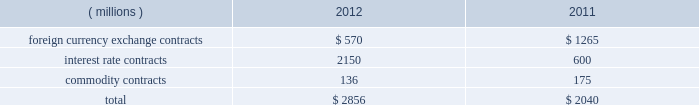Note 12 derivative instruments and fair value measurements the company is exposed to certain market risks such as changes in interest rates , foreign currency exchange rates , and commodity prices , which exist as a part of its ongoing business operations .
Management uses derivative financial and commodity instruments , including futures , options , and swaps , where appropriate , to manage these risks .
Instruments used as hedges must be effective at reducing the risk associated with the exposure being hedged and must be designated as a hedge at the inception of the contract .
The company designates derivatives as cash flow hedges , fair value hedges , net investment hedges , and uses other contracts to reduce volatility in interest rates , foreign currency and commodities .
As a matter of policy , the company does not engage in trading or speculative hedging transactions .
Total notional amounts of the company 2019s derivative instruments as of december 29 , 2012 and december 31 , 2011 were as follows: .
Following is a description of each category in the fair value hierarchy and the financial assets and liabilities of the company that were included in each category at december 29 , 2012 and december 31 , 2011 , measured on a recurring basis .
Level 1 2014 financial assets and liabilities whose values are based on unadjusted quoted prices for identical assets or liabilities in an active market .
For the company , level 1 financial assets and liabilities consist primarily of commodity derivative contracts .
Level 2 2014 financial assets and liabilities whose values are based on quoted prices in markets that are not active or model inputs that are observable either directly or indirectly for substantially the full term of the asset or liability .
For the company , level 2 financial assets and liabilities consist of interest rate swaps and over-the-counter commodity and currency contracts .
The company 2019s calculation of the fair value of interest rate swaps is derived from a discounted cash flow analysis based on the terms of the contract and the interest rate curve .
Over-the-counter commodity derivatives are valued using an income approach based on the commodity index prices less the contract rate multiplied by the notional amount .
Foreign currency contracts are valued using an income approach based on forward rates less the contract rate multiplied by the notional amount .
The company 2019s calculation of the fair value of level 2 financial assets and liabilities takes into consideration the risk of nonperformance , including counterparty credit risk .
Level 3 2014 financial assets and liabilities whose values are based on prices or valuation techniques that require inputs that are both unobservable and significant to the overall fair value measurement .
These inputs reflect management 2019s own assumptions about the assumptions a market participant would use in pricing the asset or liability .
The company did not have any level 3 financial assets or liabilities as of december 29 , 2012 or december 31 , 2011 .
The following table presents assets and liabilities that were measured at fair value in the consolidated balance sheet on a recurring basis as of december 29 , 2012 and december 31 , 2011 : derivatives designated as hedging instruments : 2012 2011 ( millions ) level 1 level 2 total level 1 level 2 total assets : foreign currency exchange contracts : other current assets $ 2014 $ 4 $ 4 $ 2014 $ 11 $ 11 interest rate contracts ( a ) : other assets 2014 64 64 2014 23 23 commodity contracts : other current assets 2014 2014 2014 2 2014 2 total assets $ 2014 $ 68 $ 68 $ 2 $ 34 $ 36 liabilities : foreign currency exchange contracts : other current liabilities $ 2014 $ ( 3 ) $ ( 3 ) $ 2014 $ ( 18 ) $ ( 18 ) commodity contracts : other current liabilities 2014 ( 11 ) ( 11 ) ( 4 ) ( 12 ) ( 16 ) other liabilities 2014 ( 27 ) ( 27 ) 2014 ( 34 ) ( 34 ) total liabilities $ 2014 $ ( 41 ) $ ( 41 ) $ ( 4 ) $ ( 64 ) $ ( 68 ) ( a ) the fair value of the related hedged portion of the company 2019s long-term debt , a level 2 liability , was $ 2.3 billion as of december 29 , 2012 and $ 626 million as of december 31 , derivatives not designated as hedging instruments : 2012 2011 ( millions ) level 1 level 2 total level 1 level 2 total assets : commodity contracts : other current assets $ 5 $ 2014 $ 5 $ 2014 $ 2014 $ 2014 total assets $ 5 $ 2014 $ 5 $ 2014 $ 2014 $ 2014 liabilities : commodity contracts : other current liabilities $ ( 3 ) $ 2014 $ ( 3 ) $ 2014 $ 2014 $ 2014 total liabilities $ ( 3 ) $ 2014 $ ( 3 ) $ 2014 $ 2014 $ 2014 .
In 2012 , what percent of the total notional amount is from foreign currency exchange contracts? 
Computations: (570 / 2856)
Answer: 0.19958. Note 12 derivative instruments and fair value measurements the company is exposed to certain market risks such as changes in interest rates , foreign currency exchange rates , and commodity prices , which exist as a part of its ongoing business operations .
Management uses derivative financial and commodity instruments , including futures , options , and swaps , where appropriate , to manage these risks .
Instruments used as hedges must be effective at reducing the risk associated with the exposure being hedged and must be designated as a hedge at the inception of the contract .
The company designates derivatives as cash flow hedges , fair value hedges , net investment hedges , and uses other contracts to reduce volatility in interest rates , foreign currency and commodities .
As a matter of policy , the company does not engage in trading or speculative hedging transactions .
Total notional amounts of the company 2019s derivative instruments as of december 29 , 2012 and december 31 , 2011 were as follows: .
Following is a description of each category in the fair value hierarchy and the financial assets and liabilities of the company that were included in each category at december 29 , 2012 and december 31 , 2011 , measured on a recurring basis .
Level 1 2014 financial assets and liabilities whose values are based on unadjusted quoted prices for identical assets or liabilities in an active market .
For the company , level 1 financial assets and liabilities consist primarily of commodity derivative contracts .
Level 2 2014 financial assets and liabilities whose values are based on quoted prices in markets that are not active or model inputs that are observable either directly or indirectly for substantially the full term of the asset or liability .
For the company , level 2 financial assets and liabilities consist of interest rate swaps and over-the-counter commodity and currency contracts .
The company 2019s calculation of the fair value of interest rate swaps is derived from a discounted cash flow analysis based on the terms of the contract and the interest rate curve .
Over-the-counter commodity derivatives are valued using an income approach based on the commodity index prices less the contract rate multiplied by the notional amount .
Foreign currency contracts are valued using an income approach based on forward rates less the contract rate multiplied by the notional amount .
The company 2019s calculation of the fair value of level 2 financial assets and liabilities takes into consideration the risk of nonperformance , including counterparty credit risk .
Level 3 2014 financial assets and liabilities whose values are based on prices or valuation techniques that require inputs that are both unobservable and significant to the overall fair value measurement .
These inputs reflect management 2019s own assumptions about the assumptions a market participant would use in pricing the asset or liability .
The company did not have any level 3 financial assets or liabilities as of december 29 , 2012 or december 31 , 2011 .
The following table presents assets and liabilities that were measured at fair value in the consolidated balance sheet on a recurring basis as of december 29 , 2012 and december 31 , 2011 : derivatives designated as hedging instruments : 2012 2011 ( millions ) level 1 level 2 total level 1 level 2 total assets : foreign currency exchange contracts : other current assets $ 2014 $ 4 $ 4 $ 2014 $ 11 $ 11 interest rate contracts ( a ) : other assets 2014 64 64 2014 23 23 commodity contracts : other current assets 2014 2014 2014 2 2014 2 total assets $ 2014 $ 68 $ 68 $ 2 $ 34 $ 36 liabilities : foreign currency exchange contracts : other current liabilities $ 2014 $ ( 3 ) $ ( 3 ) $ 2014 $ ( 18 ) $ ( 18 ) commodity contracts : other current liabilities 2014 ( 11 ) ( 11 ) ( 4 ) ( 12 ) ( 16 ) other liabilities 2014 ( 27 ) ( 27 ) 2014 ( 34 ) ( 34 ) total liabilities $ 2014 $ ( 41 ) $ ( 41 ) $ ( 4 ) $ ( 64 ) $ ( 68 ) ( a ) the fair value of the related hedged portion of the company 2019s long-term debt , a level 2 liability , was $ 2.3 billion as of december 29 , 2012 and $ 626 million as of december 31 , derivatives not designated as hedging instruments : 2012 2011 ( millions ) level 1 level 2 total level 1 level 2 total assets : commodity contracts : other current assets $ 5 $ 2014 $ 5 $ 2014 $ 2014 $ 2014 total assets $ 5 $ 2014 $ 5 $ 2014 $ 2014 $ 2014 liabilities : commodity contracts : other current liabilities $ ( 3 ) $ 2014 $ ( 3 ) $ 2014 $ 2014 $ 2014 total liabilities $ ( 3 ) $ 2014 $ ( 3 ) $ 2014 $ 2014 $ 2014 .
By what percent did the total notional amount of the company's derivatives increase between 2011 and 2012? 
Computations: ((2856 - 2040) / 2040)
Answer: 0.4. 